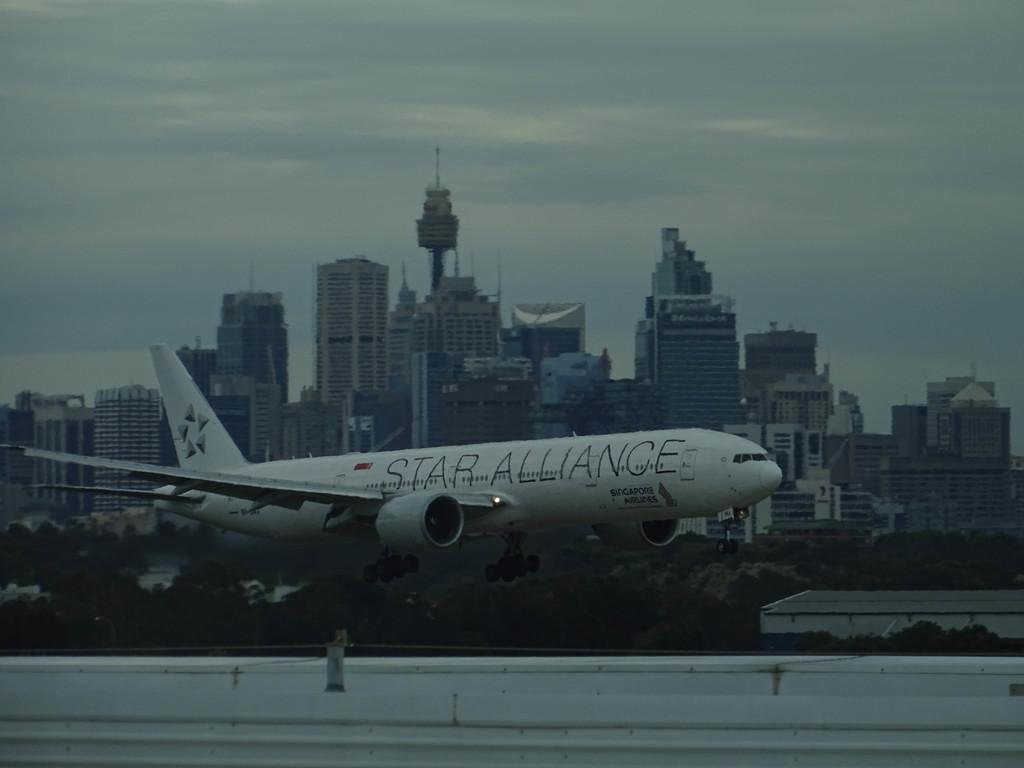<image>
Write a terse but informative summary of the picture. A Star Alliance plane is just above the runway with a large city behind it. 